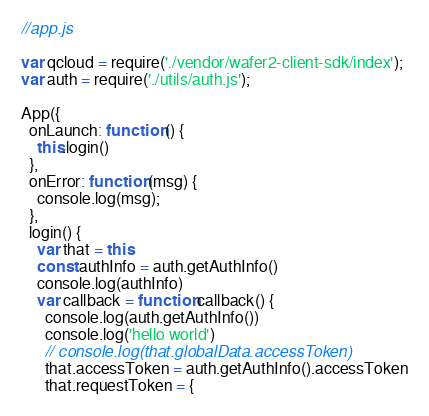Convert code to text. <code><loc_0><loc_0><loc_500><loc_500><_JavaScript_>//app.js

var qcloud = require('./vendor/wafer2-client-sdk/index');
var auth = require('./utils/auth.js');

App({
  onLaunch: function () {
    this.login()
  },
  onError: function (msg) {
    console.log(msg);
  },
  login() {
    var that = this
    const authInfo = auth.getAuthInfo()
    console.log(authInfo)
    var callback = function callback() {
      console.log(auth.getAuthInfo())
      console.log('hello world')
      // console.log(that.globalData.accessToken)
      that.accessToken = auth.getAuthInfo().accessToken
      that.requestToken = {</code> 